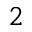Convert formula to latex. <formula><loc_0><loc_0><loc_500><loc_500>^ { 2 }</formula> 